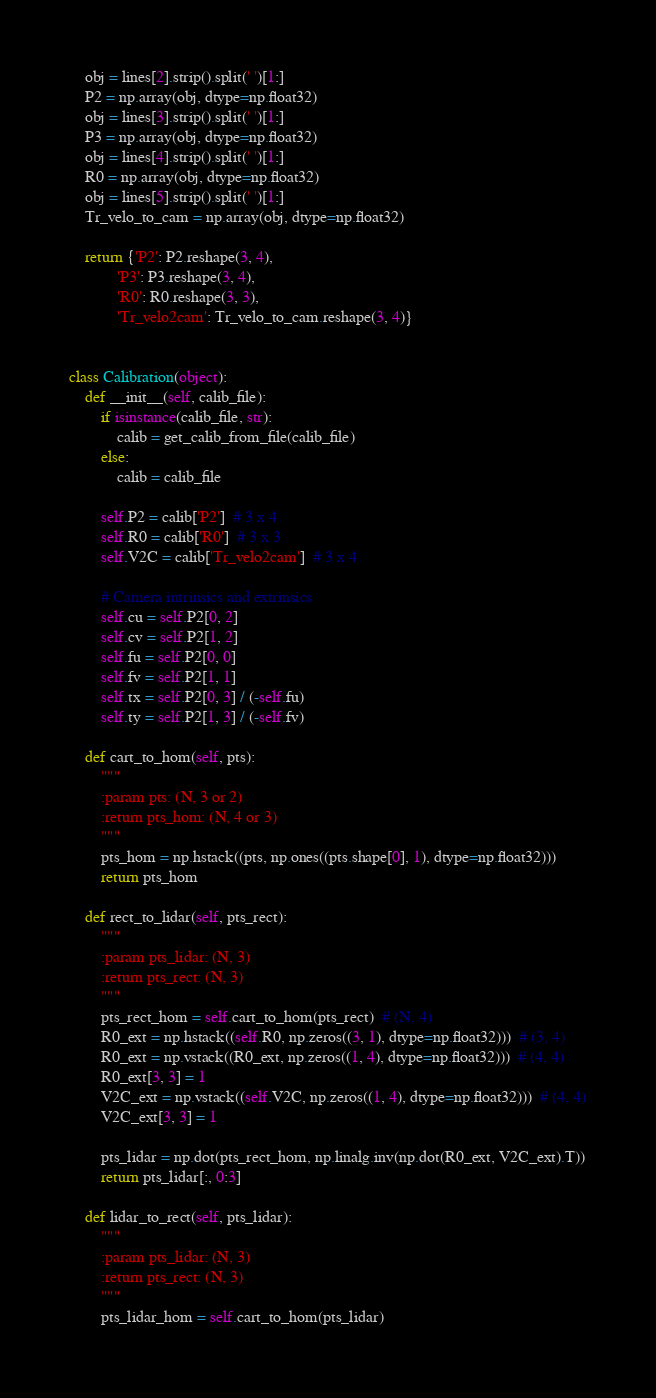<code> <loc_0><loc_0><loc_500><loc_500><_Python_>
    obj = lines[2].strip().split(' ')[1:]
    P2 = np.array(obj, dtype=np.float32)
    obj = lines[3].strip().split(' ')[1:]
    P3 = np.array(obj, dtype=np.float32)
    obj = lines[4].strip().split(' ')[1:]
    R0 = np.array(obj, dtype=np.float32)
    obj = lines[5].strip().split(' ')[1:]
    Tr_velo_to_cam = np.array(obj, dtype=np.float32)

    return {'P2': P2.reshape(3, 4),
            'P3': P3.reshape(3, 4),
            'R0': R0.reshape(3, 3),
            'Tr_velo2cam': Tr_velo_to_cam.reshape(3, 4)}


class Calibration(object):
    def __init__(self, calib_file):
        if isinstance(calib_file, str):
            calib = get_calib_from_file(calib_file)
        else:
            calib = calib_file

        self.P2 = calib['P2']  # 3 x 4
        self.R0 = calib['R0']  # 3 x 3
        self.V2C = calib['Tr_velo2cam']  # 3 x 4

        # Camera intrinsics and extrinsics
        self.cu = self.P2[0, 2]
        self.cv = self.P2[1, 2]
        self.fu = self.P2[0, 0]
        self.fv = self.P2[1, 1]
        self.tx = self.P2[0, 3] / (-self.fu)
        self.ty = self.P2[1, 3] / (-self.fv)

    def cart_to_hom(self, pts):
        """
        :param pts: (N, 3 or 2)
        :return pts_hom: (N, 4 or 3)
        """
        pts_hom = np.hstack((pts, np.ones((pts.shape[0], 1), dtype=np.float32)))
        return pts_hom

    def rect_to_lidar(self, pts_rect):
        """
        :param pts_lidar: (N, 3)
        :return pts_rect: (N, 3)
        """
        pts_rect_hom = self.cart_to_hom(pts_rect)  # (N, 4)
        R0_ext = np.hstack((self.R0, np.zeros((3, 1), dtype=np.float32)))  # (3, 4)
        R0_ext = np.vstack((R0_ext, np.zeros((1, 4), dtype=np.float32)))  # (4, 4)
        R0_ext[3, 3] = 1
        V2C_ext = np.vstack((self.V2C, np.zeros((1, 4), dtype=np.float32)))  # (4, 4)
        V2C_ext[3, 3] = 1

        pts_lidar = np.dot(pts_rect_hom, np.linalg.inv(np.dot(R0_ext, V2C_ext).T))
        return pts_lidar[:, 0:3]

    def lidar_to_rect(self, pts_lidar):
        """
        :param pts_lidar: (N, 3)
        :return pts_rect: (N, 3)
        """
        pts_lidar_hom = self.cart_to_hom(pts_lidar)</code> 